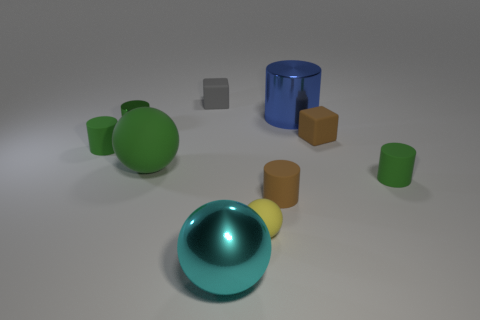What number of cylinders have the same color as the large matte ball?
Provide a short and direct response. 3. There is a shiny thing that is to the left of the small yellow rubber ball and right of the big green thing; what size is it?
Provide a succinct answer. Large. What material is the big sphere that is on the right side of the tiny gray rubber thing?
Provide a succinct answer. Metal. Is there another object that has the same shape as the tiny yellow object?
Offer a terse response. Yes. How many other objects are the same shape as the tiny metallic thing?
Your response must be concise. 4. Does the small yellow object have the same shape as the big object that is left of the large cyan ball?
Offer a very short reply. Yes. There is a brown thing that is the same shape as the tiny green metallic object; what is its material?
Your response must be concise. Rubber. How many big things are either blue matte cylinders or brown objects?
Your answer should be compact. 0. Is the number of gray cubes that are in front of the big rubber object less than the number of tiny rubber things behind the tiny green shiny cylinder?
Your response must be concise. Yes. What number of things are blue things or brown cubes?
Keep it short and to the point. 2. 